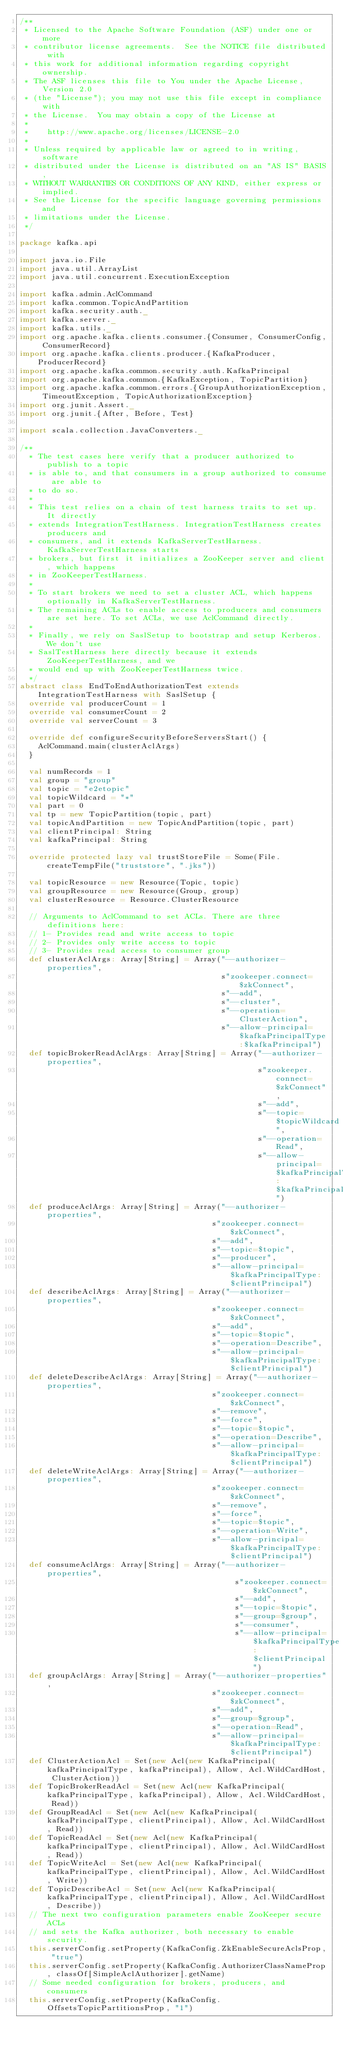Convert code to text. <code><loc_0><loc_0><loc_500><loc_500><_Scala_>/**
 * Licensed to the Apache Software Foundation (ASF) under one or more
 * contributor license agreements.  See the NOTICE file distributed with
 * this work for additional information regarding copyright ownership.
 * The ASF licenses this file to You under the Apache License, Version 2.0
 * (the "License"); you may not use this file except in compliance with
 * the License.  You may obtain a copy of the License at
 * 
 *    http://www.apache.org/licenses/LICENSE-2.0
 *
 * Unless required by applicable law or agreed to in writing, software
 * distributed under the License is distributed on an "AS IS" BASIS,
 * WITHOUT WARRANTIES OR CONDITIONS OF ANY KIND, either express or implied.
 * See the License for the specific language governing permissions and
 * limitations under the License.
 */

package kafka.api

import java.io.File
import java.util.ArrayList
import java.util.concurrent.ExecutionException

import kafka.admin.AclCommand
import kafka.common.TopicAndPartition
import kafka.security.auth._
import kafka.server._
import kafka.utils._
import org.apache.kafka.clients.consumer.{Consumer, ConsumerConfig, ConsumerRecord}
import org.apache.kafka.clients.producer.{KafkaProducer, ProducerRecord}
import org.apache.kafka.common.security.auth.KafkaPrincipal
import org.apache.kafka.common.{KafkaException, TopicPartition}
import org.apache.kafka.common.errors.{GroupAuthorizationException, TimeoutException, TopicAuthorizationException}
import org.junit.Assert._
import org.junit.{After, Before, Test}

import scala.collection.JavaConverters._

/**
  * The test cases here verify that a producer authorized to publish to a topic
  * is able to, and that consumers in a group authorized to consume are able to
  * to do so.
  *
  * This test relies on a chain of test harness traits to set up. It directly
  * extends IntegrationTestHarness. IntegrationTestHarness creates producers and
  * consumers, and it extends KafkaServerTestHarness. KafkaServerTestHarness starts
  * brokers, but first it initializes a ZooKeeper server and client, which happens
  * in ZooKeeperTestHarness.
  *
  * To start brokers we need to set a cluster ACL, which happens optionally in KafkaServerTestHarness.
  * The remaining ACLs to enable access to producers and consumers are set here. To set ACLs, we use AclCommand directly.
  *
  * Finally, we rely on SaslSetup to bootstrap and setup Kerberos. We don't use
  * SaslTestHarness here directly because it extends ZooKeeperTestHarness, and we
  * would end up with ZooKeeperTestHarness twice.
  */
abstract class EndToEndAuthorizationTest extends IntegrationTestHarness with SaslSetup {
  override val producerCount = 1
  override val consumerCount = 2
  override val serverCount = 3

  override def configureSecurityBeforeServersStart() {
    AclCommand.main(clusterAclArgs)
  }

  val numRecords = 1
  val group = "group"
  val topic = "e2etopic"
  val topicWildcard = "*"
  val part = 0
  val tp = new TopicPartition(topic, part)
  val topicAndPartition = new TopicAndPartition(topic, part)
  val clientPrincipal: String
  val kafkaPrincipal: String

  override protected lazy val trustStoreFile = Some(File.createTempFile("truststore", ".jks"))

  val topicResource = new Resource(Topic, topic)
  val groupResource = new Resource(Group, group)
  val clusterResource = Resource.ClusterResource

  // Arguments to AclCommand to set ACLs. There are three definitions here:
  // 1- Provides read and write access to topic
  // 2- Provides only write access to topic
  // 3- Provides read access to consumer group
  def clusterAclArgs: Array[String] = Array("--authorizer-properties",
                                            s"zookeeper.connect=$zkConnect",
                                            s"--add",
                                            s"--cluster",
                                            s"--operation=ClusterAction",
                                            s"--allow-principal=$kafkaPrincipalType:$kafkaPrincipal")
  def topicBrokerReadAclArgs: Array[String] = Array("--authorizer-properties",
                                                    s"zookeeper.connect=$zkConnect",
                                                    s"--add",
                                                    s"--topic=$topicWildcard",
                                                    s"--operation=Read",
                                                    s"--allow-principal=$kafkaPrincipalType:$kafkaPrincipal")
  def produceAclArgs: Array[String] = Array("--authorizer-properties",
                                          s"zookeeper.connect=$zkConnect",
                                          s"--add",
                                          s"--topic=$topic",
                                          s"--producer",
                                          s"--allow-principal=$kafkaPrincipalType:$clientPrincipal")
  def describeAclArgs: Array[String] = Array("--authorizer-properties",
                                          s"zookeeper.connect=$zkConnect",
                                          s"--add",
                                          s"--topic=$topic",
                                          s"--operation=Describe",
                                          s"--allow-principal=$kafkaPrincipalType:$clientPrincipal")
  def deleteDescribeAclArgs: Array[String] = Array("--authorizer-properties",
                                          s"zookeeper.connect=$zkConnect",
                                          s"--remove",
                                          s"--force",
                                          s"--topic=$topic",
                                          s"--operation=Describe",
                                          s"--allow-principal=$kafkaPrincipalType:$clientPrincipal")
  def deleteWriteAclArgs: Array[String] = Array("--authorizer-properties",
                                          s"zookeeper.connect=$zkConnect",
                                          s"--remove",
                                          s"--force",
                                          s"--topic=$topic",
                                          s"--operation=Write",
                                          s"--allow-principal=$kafkaPrincipalType:$clientPrincipal")
  def consumeAclArgs: Array[String] = Array("--authorizer-properties",
                                               s"zookeeper.connect=$zkConnect",
                                               s"--add",
                                               s"--topic=$topic",
                                               s"--group=$group",
                                               s"--consumer",
                                               s"--allow-principal=$kafkaPrincipalType:$clientPrincipal")
  def groupAclArgs: Array[String] = Array("--authorizer-properties",
                                          s"zookeeper.connect=$zkConnect",
                                          s"--add",
                                          s"--group=$group",
                                          s"--operation=Read",
                                          s"--allow-principal=$kafkaPrincipalType:$clientPrincipal")
  def ClusterActionAcl = Set(new Acl(new KafkaPrincipal(kafkaPrincipalType, kafkaPrincipal), Allow, Acl.WildCardHost, ClusterAction))
  def TopicBrokerReadAcl = Set(new Acl(new KafkaPrincipal(kafkaPrincipalType, kafkaPrincipal), Allow, Acl.WildCardHost, Read))
  def GroupReadAcl = Set(new Acl(new KafkaPrincipal(kafkaPrincipalType, clientPrincipal), Allow, Acl.WildCardHost, Read))
  def TopicReadAcl = Set(new Acl(new KafkaPrincipal(kafkaPrincipalType, clientPrincipal), Allow, Acl.WildCardHost, Read))
  def TopicWriteAcl = Set(new Acl(new KafkaPrincipal(kafkaPrincipalType, clientPrincipal), Allow, Acl.WildCardHost, Write))
  def TopicDescribeAcl = Set(new Acl(new KafkaPrincipal(kafkaPrincipalType, clientPrincipal), Allow, Acl.WildCardHost, Describe))
  // The next two configuration parameters enable ZooKeeper secure ACLs
  // and sets the Kafka authorizer, both necessary to enable security.
  this.serverConfig.setProperty(KafkaConfig.ZkEnableSecureAclsProp, "true")
  this.serverConfig.setProperty(KafkaConfig.AuthorizerClassNameProp, classOf[SimpleAclAuthorizer].getName)
  // Some needed configuration for brokers, producers, and consumers
  this.serverConfig.setProperty(KafkaConfig.OffsetsTopicPartitionsProp, "1")</code> 